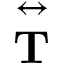<formula> <loc_0><loc_0><loc_500><loc_500>\overset { \leftrightarrow } T }</formula> 